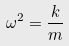Convert formula to latex. <formula><loc_0><loc_0><loc_500><loc_500>\omega ^ { 2 } = \frac { k } { m }</formula> 